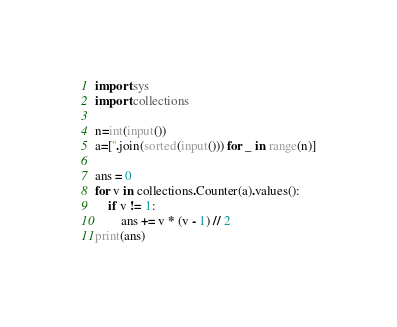Convert code to text. <code><loc_0><loc_0><loc_500><loc_500><_Python_>import sys
import collections

n=int(input())
a=[''.join(sorted(input())) for _ in range(n)]

ans = 0
for v in collections.Counter(a).values():
    if v != 1:
        ans += v * (v - 1) // 2
print(ans)</code> 